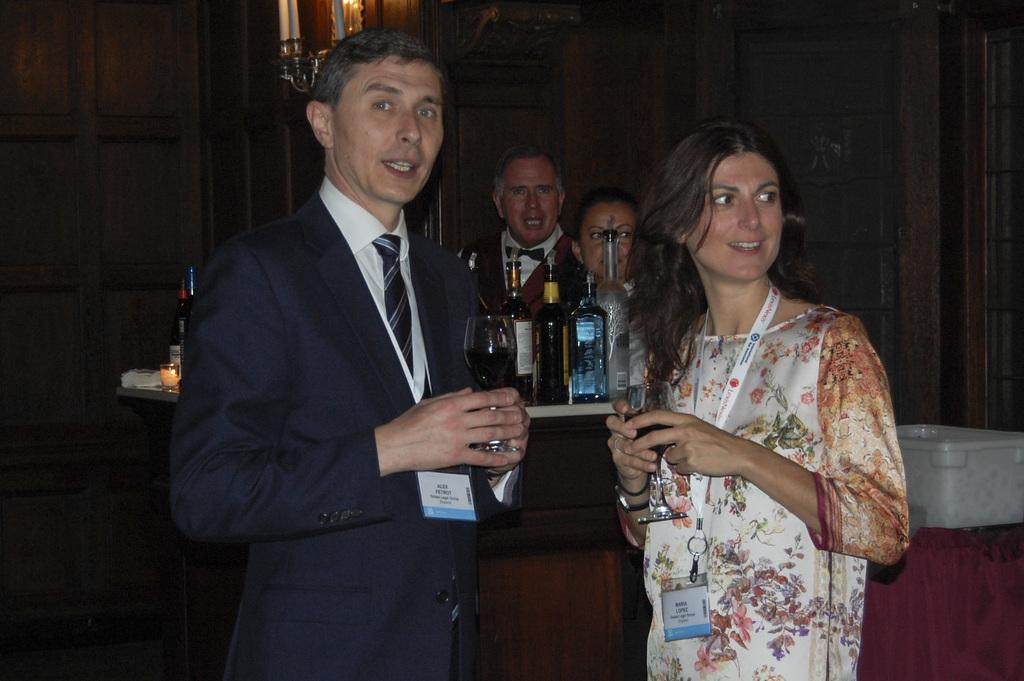How many people are in the image? There are two people in the image. What are the people holding in their hands? The people are holding glasses. Can you describe any additional items the people are wearing? The people are wearing ID cards. What can be seen on the tables in the image? There are bottles on the tables. What is the position of the people behind the tables? There are people behind the tables. Are there any decorative elements visible in the image? Yes, there are candles in the image. What type of beast can be seen roaming around the market in the image? There is no market or beast present in the image. What is the purpose of the pan in the image? There is no pan present in the image. 